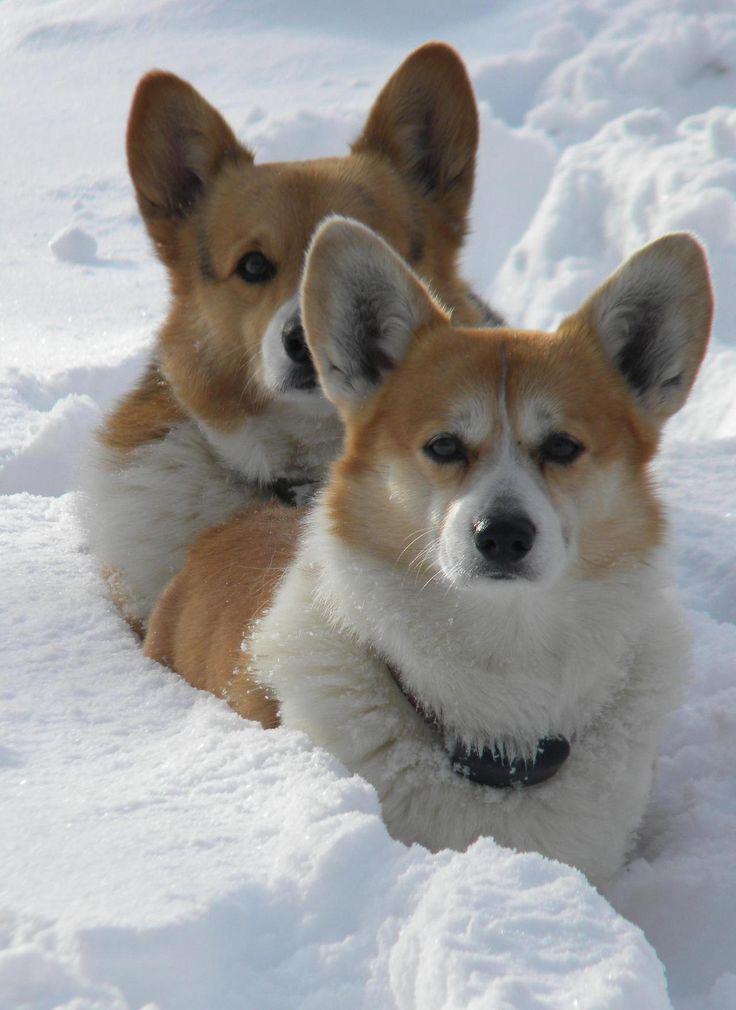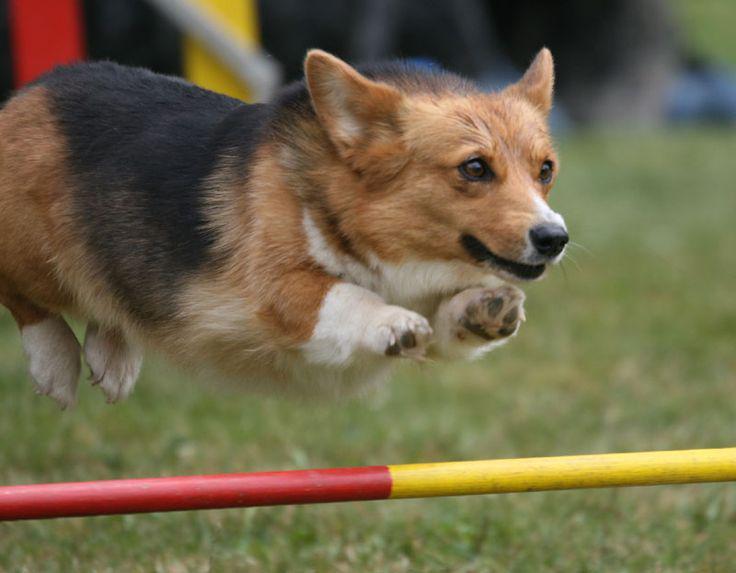The first image is the image on the left, the second image is the image on the right. Assess this claim about the two images: "There are three dogs in total.". Correct or not? Answer yes or no. Yes. The first image is the image on the left, the second image is the image on the right. Given the left and right images, does the statement "An image shows one orange-and-white dog, which is sprawling flat on its belly." hold true? Answer yes or no. No. 